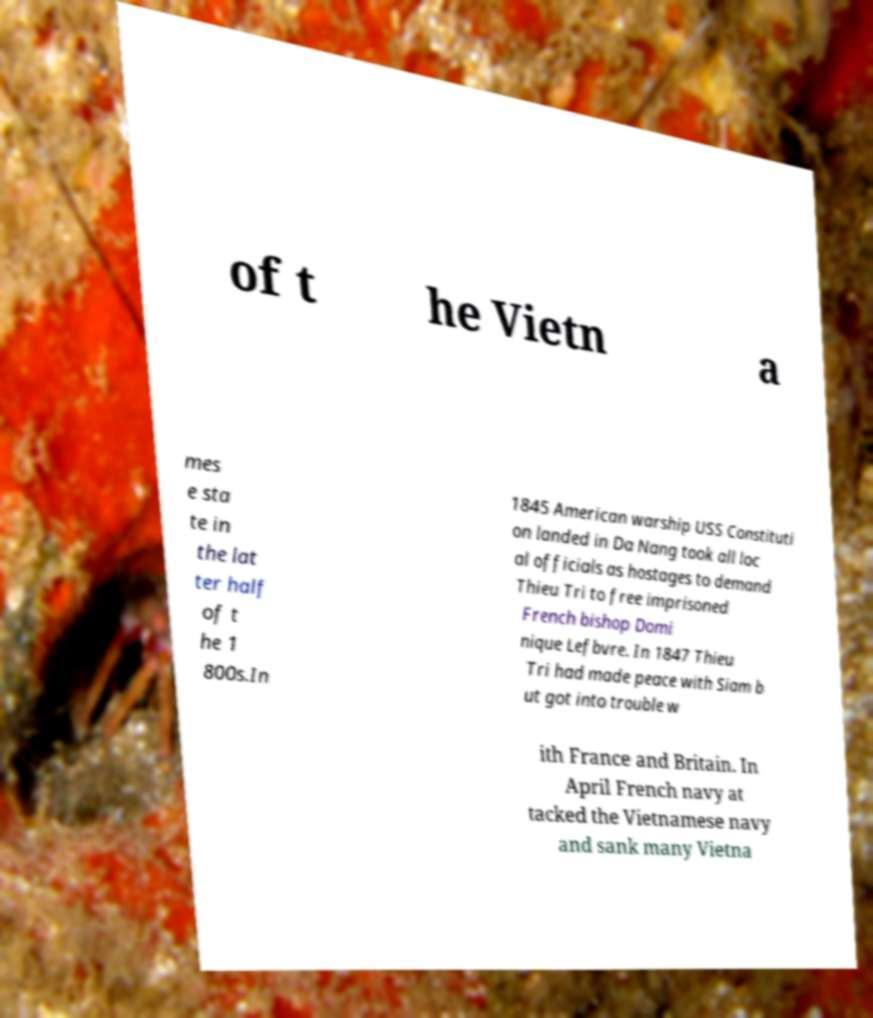There's text embedded in this image that I need extracted. Can you transcribe it verbatim? of t he Vietn a mes e sta te in the lat ter half of t he 1 800s.In 1845 American warship USS Constituti on landed in Da Nang took all loc al officials as hostages to demand Thieu Tri to free imprisoned French bishop Domi nique Lefbvre. In 1847 Thieu Tri had made peace with Siam b ut got into trouble w ith France and Britain. In April French navy at tacked the Vietnamese navy and sank many Vietna 